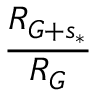<formula> <loc_0><loc_0><loc_500><loc_500>\frac { R _ { G + s _ { * } } } { R _ { G } }</formula> 